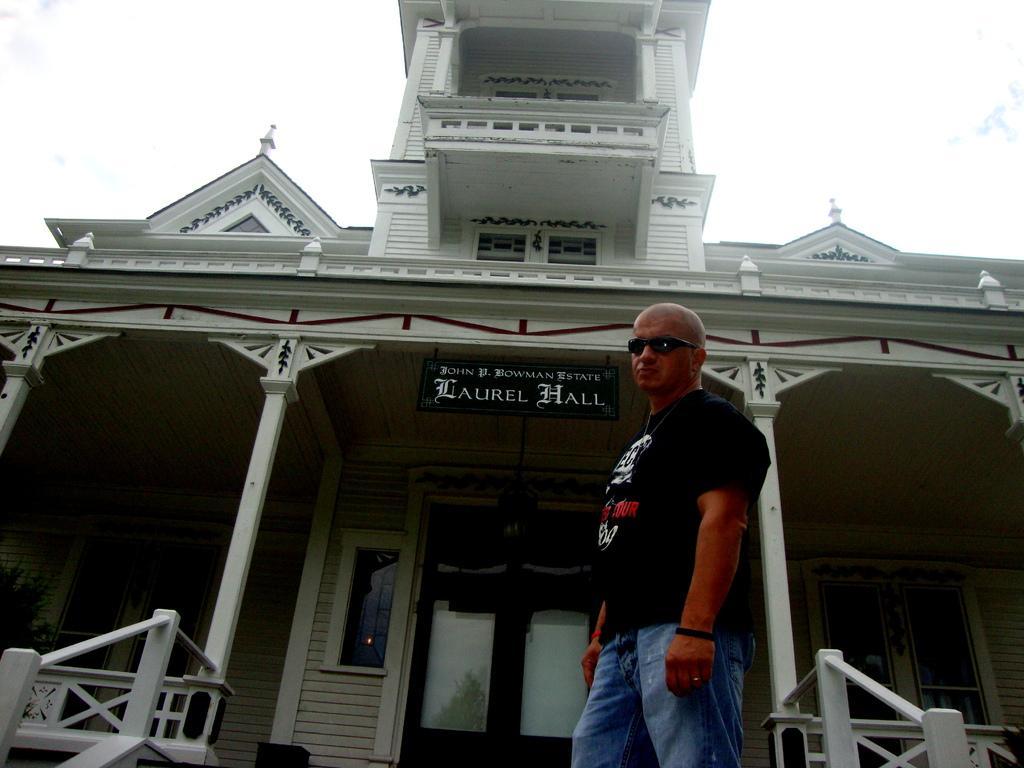Could you give a brief overview of what you see in this image? In this image I can see the person standing and wearing the black and blue color dress and also goggles. To the side of the person I can see the building which is in white color. And there is a black color board to the building. In the background there is a sky. 